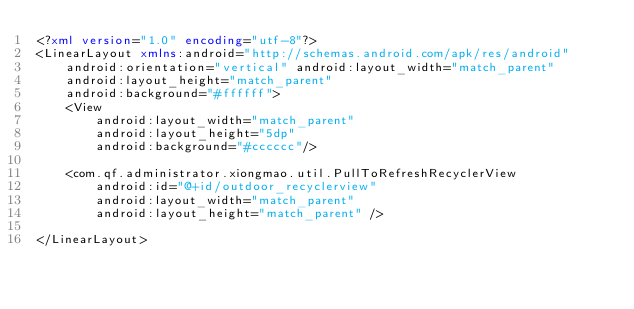Convert code to text. <code><loc_0><loc_0><loc_500><loc_500><_XML_><?xml version="1.0" encoding="utf-8"?>
<LinearLayout xmlns:android="http://schemas.android.com/apk/res/android"
    android:orientation="vertical" android:layout_width="match_parent"
    android:layout_height="match_parent"
    android:background="#ffffff">
    <View
        android:layout_width="match_parent"
        android:layout_height="5dp"
        android:background="#cccccc"/>

    <com.qf.administrator.xiongmao.util.PullToRefreshRecyclerView
        android:id="@+id/outdoor_recyclerview"
        android:layout_width="match_parent"
        android:layout_height="match_parent" />

</LinearLayout></code> 